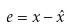<formula> <loc_0><loc_0><loc_500><loc_500>e = x - \hat { x }</formula> 